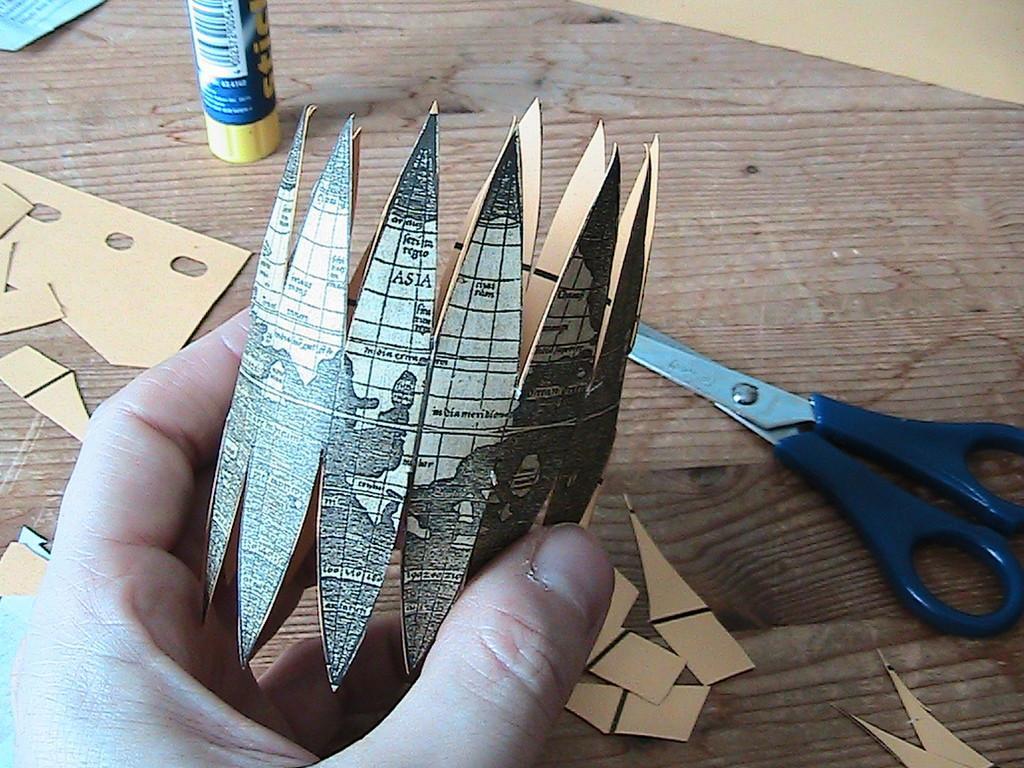In one or two sentences, can you explain what this image depicts? In this image I can see hand of a person holding an object. There are papers, there is a glue stick and scissor on the table. 